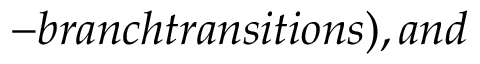Convert formula to latex. <formula><loc_0><loc_0><loc_500><loc_500>- b r a n c h t r a n s i t i o n s ) , a n d</formula> 